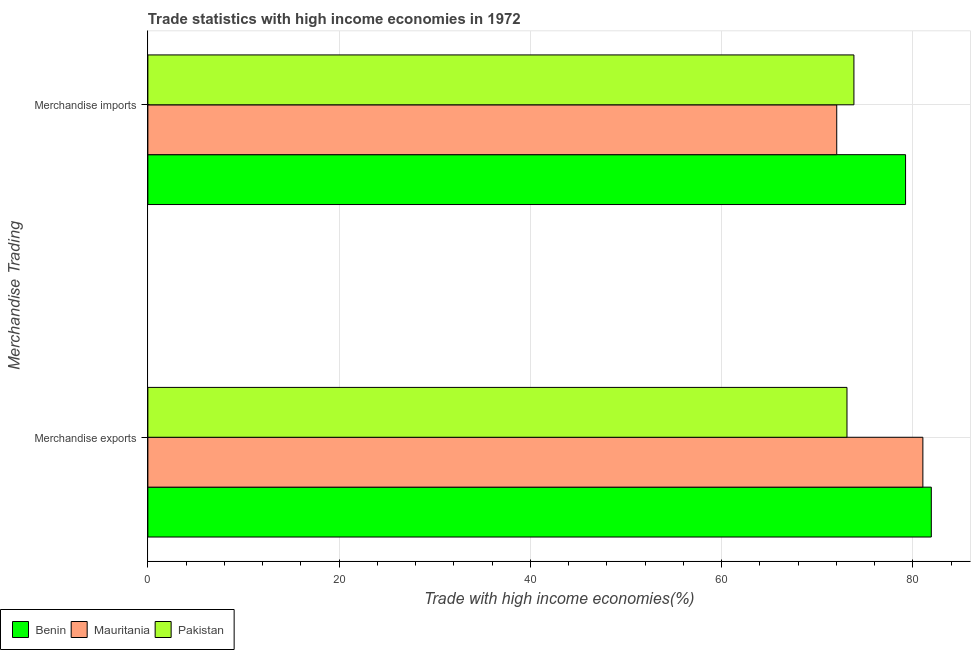How many different coloured bars are there?
Your answer should be compact. 3. How many groups of bars are there?
Your answer should be compact. 2. Are the number of bars per tick equal to the number of legend labels?
Give a very brief answer. Yes. Are the number of bars on each tick of the Y-axis equal?
Provide a short and direct response. Yes. How many bars are there on the 2nd tick from the top?
Your answer should be compact. 3. What is the label of the 2nd group of bars from the top?
Make the answer very short. Merchandise exports. What is the merchandise exports in Pakistan?
Ensure brevity in your answer.  73.1. Across all countries, what is the maximum merchandise exports?
Your response must be concise. 81.92. Across all countries, what is the minimum merchandise exports?
Your response must be concise. 73.1. In which country was the merchandise exports maximum?
Keep it short and to the point. Benin. In which country was the merchandise imports minimum?
Offer a terse response. Mauritania. What is the total merchandise imports in the graph?
Your answer should be compact. 225.09. What is the difference between the merchandise imports in Mauritania and that in Benin?
Your answer should be compact. -7.2. What is the difference between the merchandise imports in Benin and the merchandise exports in Pakistan?
Offer a terse response. 6.13. What is the average merchandise exports per country?
Keep it short and to the point. 78.69. What is the difference between the merchandise exports and merchandise imports in Pakistan?
Offer a terse response. -0.73. What is the ratio of the merchandise imports in Pakistan to that in Mauritania?
Give a very brief answer. 1.02. Is the merchandise exports in Mauritania less than that in Pakistan?
Ensure brevity in your answer.  No. In how many countries, is the merchandise exports greater than the average merchandise exports taken over all countries?
Your answer should be very brief. 2. What does the 3rd bar from the top in Merchandise imports represents?
Offer a very short reply. Benin. What does the 3rd bar from the bottom in Merchandise imports represents?
Keep it short and to the point. Pakistan. How many bars are there?
Your answer should be very brief. 6. Are all the bars in the graph horizontal?
Your answer should be compact. Yes. How many countries are there in the graph?
Provide a succinct answer. 3. Are the values on the major ticks of X-axis written in scientific E-notation?
Give a very brief answer. No. Where does the legend appear in the graph?
Provide a succinct answer. Bottom left. How many legend labels are there?
Offer a terse response. 3. What is the title of the graph?
Ensure brevity in your answer.  Trade statistics with high income economies in 1972. What is the label or title of the X-axis?
Your answer should be compact. Trade with high income economies(%). What is the label or title of the Y-axis?
Make the answer very short. Merchandise Trading. What is the Trade with high income economies(%) in Benin in Merchandise exports?
Offer a terse response. 81.92. What is the Trade with high income economies(%) in Mauritania in Merchandise exports?
Make the answer very short. 81.04. What is the Trade with high income economies(%) in Pakistan in Merchandise exports?
Make the answer very short. 73.1. What is the Trade with high income economies(%) in Benin in Merchandise imports?
Ensure brevity in your answer.  79.23. What is the Trade with high income economies(%) of Mauritania in Merchandise imports?
Your answer should be very brief. 72.03. What is the Trade with high income economies(%) of Pakistan in Merchandise imports?
Offer a terse response. 73.83. Across all Merchandise Trading, what is the maximum Trade with high income economies(%) in Benin?
Your response must be concise. 81.92. Across all Merchandise Trading, what is the maximum Trade with high income economies(%) in Mauritania?
Your response must be concise. 81.04. Across all Merchandise Trading, what is the maximum Trade with high income economies(%) of Pakistan?
Keep it short and to the point. 73.83. Across all Merchandise Trading, what is the minimum Trade with high income economies(%) of Benin?
Make the answer very short. 79.23. Across all Merchandise Trading, what is the minimum Trade with high income economies(%) of Mauritania?
Provide a short and direct response. 72.03. Across all Merchandise Trading, what is the minimum Trade with high income economies(%) in Pakistan?
Offer a terse response. 73.1. What is the total Trade with high income economies(%) of Benin in the graph?
Ensure brevity in your answer.  161.15. What is the total Trade with high income economies(%) in Mauritania in the graph?
Give a very brief answer. 153.07. What is the total Trade with high income economies(%) of Pakistan in the graph?
Keep it short and to the point. 146.93. What is the difference between the Trade with high income economies(%) of Benin in Merchandise exports and that in Merchandise imports?
Provide a succinct answer. 2.69. What is the difference between the Trade with high income economies(%) of Mauritania in Merchandise exports and that in Merchandise imports?
Ensure brevity in your answer.  9.01. What is the difference between the Trade with high income economies(%) in Pakistan in Merchandise exports and that in Merchandise imports?
Provide a short and direct response. -0.73. What is the difference between the Trade with high income economies(%) in Benin in Merchandise exports and the Trade with high income economies(%) in Mauritania in Merchandise imports?
Your response must be concise. 9.89. What is the difference between the Trade with high income economies(%) in Benin in Merchandise exports and the Trade with high income economies(%) in Pakistan in Merchandise imports?
Your answer should be compact. 8.09. What is the difference between the Trade with high income economies(%) in Mauritania in Merchandise exports and the Trade with high income economies(%) in Pakistan in Merchandise imports?
Your answer should be compact. 7.21. What is the average Trade with high income economies(%) of Benin per Merchandise Trading?
Provide a succinct answer. 80.57. What is the average Trade with high income economies(%) in Mauritania per Merchandise Trading?
Your response must be concise. 76.53. What is the average Trade with high income economies(%) of Pakistan per Merchandise Trading?
Make the answer very short. 73.47. What is the difference between the Trade with high income economies(%) in Benin and Trade with high income economies(%) in Mauritania in Merchandise exports?
Make the answer very short. 0.88. What is the difference between the Trade with high income economies(%) in Benin and Trade with high income economies(%) in Pakistan in Merchandise exports?
Your response must be concise. 8.82. What is the difference between the Trade with high income economies(%) of Mauritania and Trade with high income economies(%) of Pakistan in Merchandise exports?
Ensure brevity in your answer.  7.93. What is the difference between the Trade with high income economies(%) of Benin and Trade with high income economies(%) of Mauritania in Merchandise imports?
Your answer should be compact. 7.2. What is the difference between the Trade with high income economies(%) in Benin and Trade with high income economies(%) in Pakistan in Merchandise imports?
Ensure brevity in your answer.  5.4. What is the difference between the Trade with high income economies(%) of Mauritania and Trade with high income economies(%) of Pakistan in Merchandise imports?
Make the answer very short. -1.8. What is the ratio of the Trade with high income economies(%) in Benin in Merchandise exports to that in Merchandise imports?
Offer a very short reply. 1.03. What is the ratio of the Trade with high income economies(%) of Mauritania in Merchandise exports to that in Merchandise imports?
Ensure brevity in your answer.  1.12. What is the ratio of the Trade with high income economies(%) of Pakistan in Merchandise exports to that in Merchandise imports?
Make the answer very short. 0.99. What is the difference between the highest and the second highest Trade with high income economies(%) of Benin?
Keep it short and to the point. 2.69. What is the difference between the highest and the second highest Trade with high income economies(%) of Mauritania?
Ensure brevity in your answer.  9.01. What is the difference between the highest and the second highest Trade with high income economies(%) in Pakistan?
Make the answer very short. 0.73. What is the difference between the highest and the lowest Trade with high income economies(%) of Benin?
Your answer should be compact. 2.69. What is the difference between the highest and the lowest Trade with high income economies(%) of Mauritania?
Your response must be concise. 9.01. What is the difference between the highest and the lowest Trade with high income economies(%) in Pakistan?
Give a very brief answer. 0.73. 